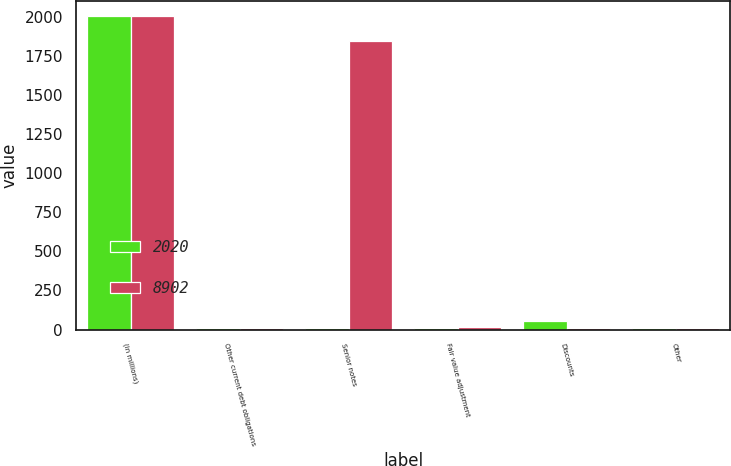Convert chart. <chart><loc_0><loc_0><loc_500><loc_500><stacked_bar_chart><ecel><fcel>(in millions)<fcel>Other current debt obligations<fcel>Senior notes<fcel>Fair value adjustment<fcel>Discounts<fcel>Other<nl><fcel>2020<fcel>2006<fcel>7<fcel>12<fcel>12<fcel>52<fcel>9<nl><fcel>8902<fcel>2005<fcel>7<fcel>1850<fcel>14<fcel>7<fcel>7<nl></chart> 